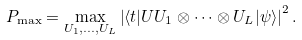<formula> <loc_0><loc_0><loc_500><loc_500>P _ { \max } = \max _ { U _ { 1 } , \dots , U _ { L } } \left | \langle t | U U _ { 1 } \otimes \dots \otimes U _ { L } | \psi \rangle \right | ^ { 2 } .</formula> 